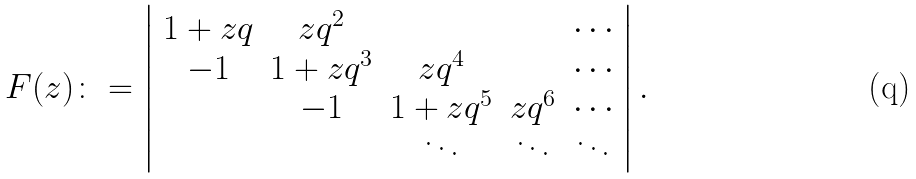Convert formula to latex. <formula><loc_0><loc_0><loc_500><loc_500>F ( z ) \colon = \left | \begin{array} { c c c c c } 1 + z q & z q ^ { 2 } & & & \cdots \\ - 1 & 1 + z q ^ { 3 } & z q ^ { 4 } & & \cdots \\ & - 1 & 1 + z q ^ { 5 } & z q ^ { 6 } & \cdots \\ & & \ddots & \ddots & \ddots \\ \end{array} \right | .</formula> 